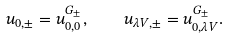<formula> <loc_0><loc_0><loc_500><loc_500>u _ { 0 , \pm } = u ^ { G _ { \pm } } _ { 0 , 0 } , \quad u _ { { \lambda V } , \pm } = u ^ { G _ { \pm } } _ { 0 , { \lambda V } } .</formula> 